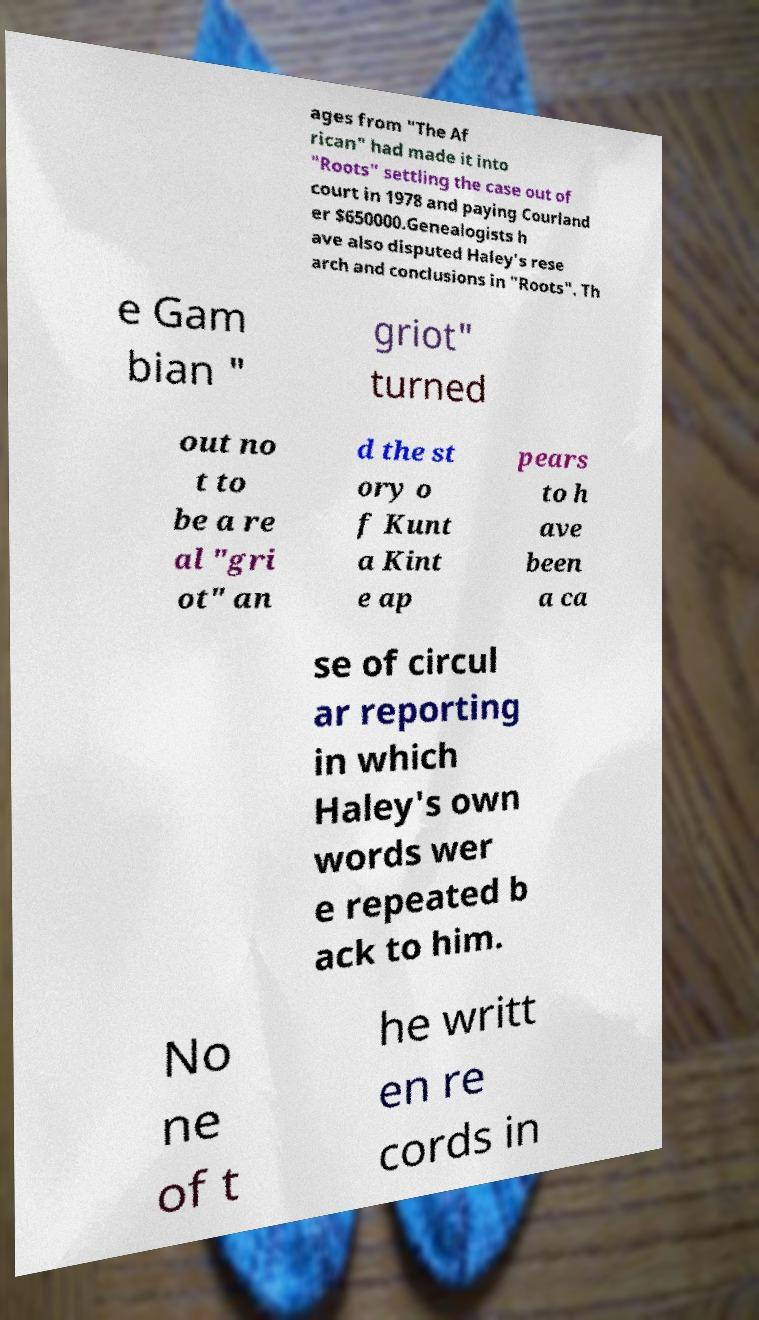For documentation purposes, I need the text within this image transcribed. Could you provide that? ages from "The Af rican" had made it into "Roots" settling the case out of court in 1978 and paying Courland er $650000.Genealogists h ave also disputed Haley's rese arch and conclusions in "Roots". Th e Gam bian " griot" turned out no t to be a re al "gri ot" an d the st ory o f Kunt a Kint e ap pears to h ave been a ca se of circul ar reporting in which Haley's own words wer e repeated b ack to him. No ne of t he writt en re cords in 